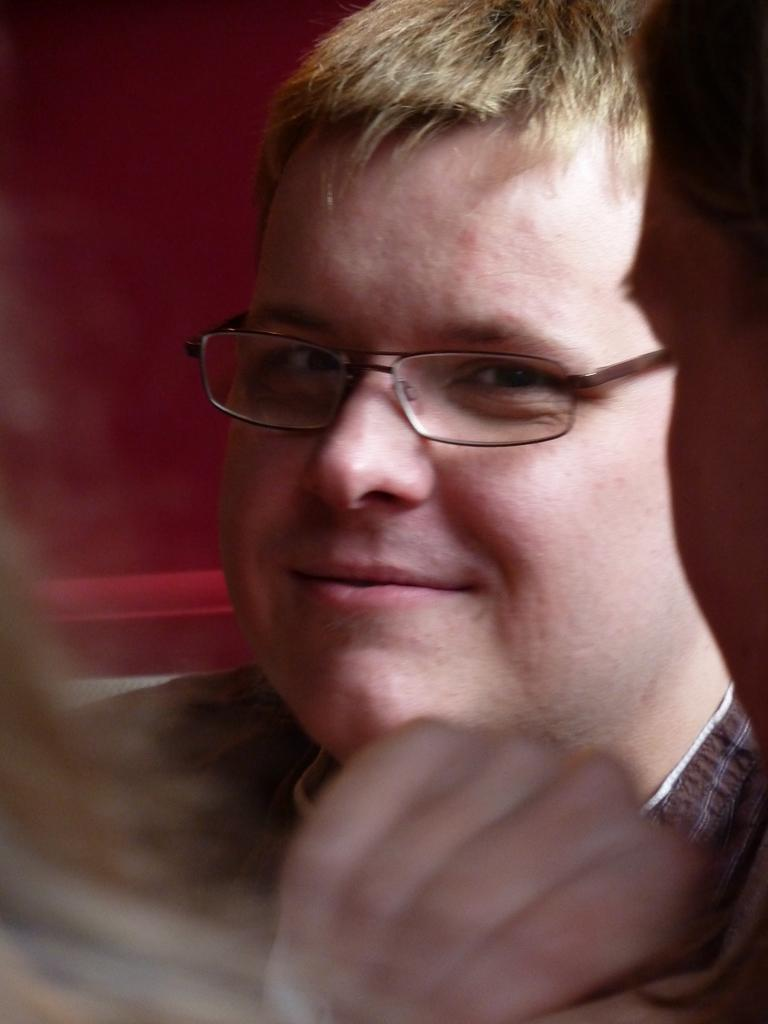What is the main subject of the image? The main subject of the image is a person's face. What is the person wearing in the image? The person is wearing goggles in the image. What expression does the person have in the image? The person is smiling in the image. What type of structure can be seen behind the person in the image? There is no structure visible behind the person in the image; it only shows the person's face. Can you tell me how many crows are sitting on the person's head in the image? There are no crows present in the image; it only shows the person's face. 